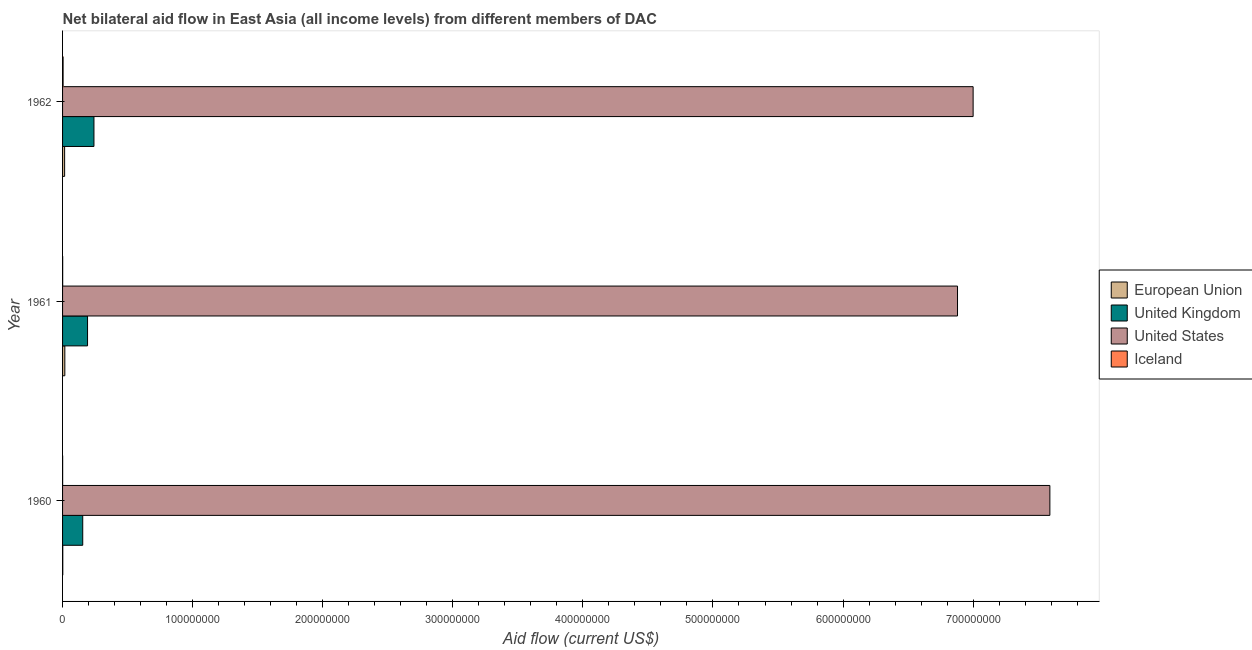How many different coloured bars are there?
Provide a succinct answer. 4. How many bars are there on the 1st tick from the top?
Keep it short and to the point. 4. What is the label of the 1st group of bars from the top?
Provide a short and direct response. 1962. In how many cases, is the number of bars for a given year not equal to the number of legend labels?
Provide a succinct answer. 0. What is the amount of aid given by uk in 1961?
Your response must be concise. 1.92e+07. Across all years, what is the maximum amount of aid given by us?
Your answer should be compact. 7.59e+08. Across all years, what is the minimum amount of aid given by uk?
Ensure brevity in your answer.  1.55e+07. In which year was the amount of aid given by iceland maximum?
Provide a succinct answer. 1962. In which year was the amount of aid given by iceland minimum?
Your answer should be very brief. 1960. What is the total amount of aid given by uk in the graph?
Your answer should be very brief. 5.88e+07. What is the difference between the amount of aid given by us in 1960 and that in 1961?
Provide a succinct answer. 7.10e+07. What is the difference between the amount of aid given by uk in 1961 and the amount of aid given by iceland in 1962?
Provide a succinct answer. 1.88e+07. What is the average amount of aid given by us per year?
Offer a terse response. 7.16e+08. In the year 1962, what is the difference between the amount of aid given by uk and amount of aid given by iceland?
Offer a terse response. 2.37e+07. In how many years, is the amount of aid given by uk greater than 740000000 US$?
Keep it short and to the point. 0. Is the amount of aid given by iceland in 1961 less than that in 1962?
Provide a succinct answer. Yes. Is the difference between the amount of aid given by us in 1960 and 1962 greater than the difference between the amount of aid given by uk in 1960 and 1962?
Give a very brief answer. Yes. What is the difference between the highest and the second highest amount of aid given by uk?
Ensure brevity in your answer.  4.92e+06. What is the difference between the highest and the lowest amount of aid given by iceland?
Your answer should be very brief. 3.40e+05. In how many years, is the amount of aid given by iceland greater than the average amount of aid given by iceland taken over all years?
Your answer should be compact. 1. Is the sum of the amount of aid given by us in 1960 and 1961 greater than the maximum amount of aid given by eu across all years?
Keep it short and to the point. Yes. What does the 3rd bar from the top in 1960 represents?
Your answer should be compact. United Kingdom. How many bars are there?
Provide a succinct answer. 12. Are all the bars in the graph horizontal?
Your answer should be very brief. Yes. How many years are there in the graph?
Ensure brevity in your answer.  3. Are the values on the major ticks of X-axis written in scientific E-notation?
Provide a short and direct response. No. Does the graph contain grids?
Provide a short and direct response. No. How many legend labels are there?
Offer a terse response. 4. How are the legend labels stacked?
Give a very brief answer. Vertical. What is the title of the graph?
Your answer should be compact. Net bilateral aid flow in East Asia (all income levels) from different members of DAC. Does "Periodicity assessment" appear as one of the legend labels in the graph?
Offer a terse response. No. What is the label or title of the Y-axis?
Offer a very short reply. Year. What is the Aid flow (current US$) of United Kingdom in 1960?
Make the answer very short. 1.55e+07. What is the Aid flow (current US$) of United States in 1960?
Your response must be concise. 7.59e+08. What is the Aid flow (current US$) in Iceland in 1960?
Your response must be concise. 6.00e+04. What is the Aid flow (current US$) of European Union in 1961?
Provide a short and direct response. 1.74e+06. What is the Aid flow (current US$) in United Kingdom in 1961?
Your answer should be very brief. 1.92e+07. What is the Aid flow (current US$) of United States in 1961?
Keep it short and to the point. 6.88e+08. What is the Aid flow (current US$) in Iceland in 1961?
Your response must be concise. 8.00e+04. What is the Aid flow (current US$) in European Union in 1962?
Provide a succinct answer. 1.58e+06. What is the Aid flow (current US$) of United Kingdom in 1962?
Keep it short and to the point. 2.41e+07. What is the Aid flow (current US$) of United States in 1962?
Give a very brief answer. 7.00e+08. Across all years, what is the maximum Aid flow (current US$) in European Union?
Keep it short and to the point. 1.74e+06. Across all years, what is the maximum Aid flow (current US$) in United Kingdom?
Provide a short and direct response. 2.41e+07. Across all years, what is the maximum Aid flow (current US$) of United States?
Your answer should be very brief. 7.59e+08. Across all years, what is the minimum Aid flow (current US$) in European Union?
Your answer should be very brief. 1.60e+05. Across all years, what is the minimum Aid flow (current US$) in United Kingdom?
Your answer should be compact. 1.55e+07. Across all years, what is the minimum Aid flow (current US$) of United States?
Your answer should be compact. 6.88e+08. What is the total Aid flow (current US$) in European Union in the graph?
Offer a terse response. 3.48e+06. What is the total Aid flow (current US$) of United Kingdom in the graph?
Keep it short and to the point. 5.88e+07. What is the total Aid flow (current US$) in United States in the graph?
Give a very brief answer. 2.15e+09. What is the total Aid flow (current US$) of Iceland in the graph?
Offer a terse response. 5.40e+05. What is the difference between the Aid flow (current US$) in European Union in 1960 and that in 1961?
Your response must be concise. -1.58e+06. What is the difference between the Aid flow (current US$) of United Kingdom in 1960 and that in 1961?
Provide a succinct answer. -3.70e+06. What is the difference between the Aid flow (current US$) of United States in 1960 and that in 1961?
Ensure brevity in your answer.  7.10e+07. What is the difference between the Aid flow (current US$) in European Union in 1960 and that in 1962?
Keep it short and to the point. -1.42e+06. What is the difference between the Aid flow (current US$) in United Kingdom in 1960 and that in 1962?
Your response must be concise. -8.62e+06. What is the difference between the Aid flow (current US$) of United States in 1960 and that in 1962?
Provide a succinct answer. 5.90e+07. What is the difference between the Aid flow (current US$) in Iceland in 1960 and that in 1962?
Provide a succinct answer. -3.40e+05. What is the difference between the Aid flow (current US$) of United Kingdom in 1961 and that in 1962?
Your answer should be very brief. -4.92e+06. What is the difference between the Aid flow (current US$) of United States in 1961 and that in 1962?
Give a very brief answer. -1.20e+07. What is the difference between the Aid flow (current US$) of Iceland in 1961 and that in 1962?
Ensure brevity in your answer.  -3.20e+05. What is the difference between the Aid flow (current US$) in European Union in 1960 and the Aid flow (current US$) in United Kingdom in 1961?
Provide a succinct answer. -1.90e+07. What is the difference between the Aid flow (current US$) in European Union in 1960 and the Aid flow (current US$) in United States in 1961?
Your response must be concise. -6.88e+08. What is the difference between the Aid flow (current US$) of European Union in 1960 and the Aid flow (current US$) of Iceland in 1961?
Your response must be concise. 8.00e+04. What is the difference between the Aid flow (current US$) of United Kingdom in 1960 and the Aid flow (current US$) of United States in 1961?
Provide a short and direct response. -6.72e+08. What is the difference between the Aid flow (current US$) of United Kingdom in 1960 and the Aid flow (current US$) of Iceland in 1961?
Keep it short and to the point. 1.54e+07. What is the difference between the Aid flow (current US$) in United States in 1960 and the Aid flow (current US$) in Iceland in 1961?
Give a very brief answer. 7.59e+08. What is the difference between the Aid flow (current US$) of European Union in 1960 and the Aid flow (current US$) of United Kingdom in 1962?
Your answer should be very brief. -2.40e+07. What is the difference between the Aid flow (current US$) in European Union in 1960 and the Aid flow (current US$) in United States in 1962?
Your answer should be compact. -7.00e+08. What is the difference between the Aid flow (current US$) of European Union in 1960 and the Aid flow (current US$) of Iceland in 1962?
Keep it short and to the point. -2.40e+05. What is the difference between the Aid flow (current US$) of United Kingdom in 1960 and the Aid flow (current US$) of United States in 1962?
Your answer should be compact. -6.84e+08. What is the difference between the Aid flow (current US$) of United Kingdom in 1960 and the Aid flow (current US$) of Iceland in 1962?
Your response must be concise. 1.51e+07. What is the difference between the Aid flow (current US$) in United States in 1960 and the Aid flow (current US$) in Iceland in 1962?
Your answer should be very brief. 7.59e+08. What is the difference between the Aid flow (current US$) in European Union in 1961 and the Aid flow (current US$) in United Kingdom in 1962?
Your response must be concise. -2.24e+07. What is the difference between the Aid flow (current US$) of European Union in 1961 and the Aid flow (current US$) of United States in 1962?
Give a very brief answer. -6.98e+08. What is the difference between the Aid flow (current US$) in European Union in 1961 and the Aid flow (current US$) in Iceland in 1962?
Your response must be concise. 1.34e+06. What is the difference between the Aid flow (current US$) in United Kingdom in 1961 and the Aid flow (current US$) in United States in 1962?
Provide a succinct answer. -6.81e+08. What is the difference between the Aid flow (current US$) of United Kingdom in 1961 and the Aid flow (current US$) of Iceland in 1962?
Provide a succinct answer. 1.88e+07. What is the difference between the Aid flow (current US$) in United States in 1961 and the Aid flow (current US$) in Iceland in 1962?
Ensure brevity in your answer.  6.88e+08. What is the average Aid flow (current US$) in European Union per year?
Keep it short and to the point. 1.16e+06. What is the average Aid flow (current US$) of United Kingdom per year?
Make the answer very short. 1.96e+07. What is the average Aid flow (current US$) in United States per year?
Your answer should be very brief. 7.16e+08. What is the average Aid flow (current US$) in Iceland per year?
Keep it short and to the point. 1.80e+05. In the year 1960, what is the difference between the Aid flow (current US$) of European Union and Aid flow (current US$) of United Kingdom?
Your answer should be very brief. -1.54e+07. In the year 1960, what is the difference between the Aid flow (current US$) of European Union and Aid flow (current US$) of United States?
Offer a terse response. -7.59e+08. In the year 1960, what is the difference between the Aid flow (current US$) of United Kingdom and Aid flow (current US$) of United States?
Give a very brief answer. -7.43e+08. In the year 1960, what is the difference between the Aid flow (current US$) in United Kingdom and Aid flow (current US$) in Iceland?
Keep it short and to the point. 1.54e+07. In the year 1960, what is the difference between the Aid flow (current US$) in United States and Aid flow (current US$) in Iceland?
Make the answer very short. 7.59e+08. In the year 1961, what is the difference between the Aid flow (current US$) in European Union and Aid flow (current US$) in United Kingdom?
Make the answer very short. -1.75e+07. In the year 1961, what is the difference between the Aid flow (current US$) of European Union and Aid flow (current US$) of United States?
Offer a very short reply. -6.86e+08. In the year 1961, what is the difference between the Aid flow (current US$) of European Union and Aid flow (current US$) of Iceland?
Offer a very short reply. 1.66e+06. In the year 1961, what is the difference between the Aid flow (current US$) of United Kingdom and Aid flow (current US$) of United States?
Offer a terse response. -6.69e+08. In the year 1961, what is the difference between the Aid flow (current US$) in United Kingdom and Aid flow (current US$) in Iceland?
Give a very brief answer. 1.91e+07. In the year 1961, what is the difference between the Aid flow (current US$) in United States and Aid flow (current US$) in Iceland?
Offer a very short reply. 6.88e+08. In the year 1962, what is the difference between the Aid flow (current US$) of European Union and Aid flow (current US$) of United Kingdom?
Your answer should be very brief. -2.26e+07. In the year 1962, what is the difference between the Aid flow (current US$) in European Union and Aid flow (current US$) in United States?
Provide a short and direct response. -6.98e+08. In the year 1962, what is the difference between the Aid flow (current US$) in European Union and Aid flow (current US$) in Iceland?
Your response must be concise. 1.18e+06. In the year 1962, what is the difference between the Aid flow (current US$) of United Kingdom and Aid flow (current US$) of United States?
Make the answer very short. -6.76e+08. In the year 1962, what is the difference between the Aid flow (current US$) of United Kingdom and Aid flow (current US$) of Iceland?
Keep it short and to the point. 2.37e+07. In the year 1962, what is the difference between the Aid flow (current US$) of United States and Aid flow (current US$) of Iceland?
Provide a succinct answer. 7.00e+08. What is the ratio of the Aid flow (current US$) in European Union in 1960 to that in 1961?
Your answer should be very brief. 0.09. What is the ratio of the Aid flow (current US$) in United Kingdom in 1960 to that in 1961?
Offer a terse response. 0.81. What is the ratio of the Aid flow (current US$) in United States in 1960 to that in 1961?
Provide a short and direct response. 1.1. What is the ratio of the Aid flow (current US$) of European Union in 1960 to that in 1962?
Provide a short and direct response. 0.1. What is the ratio of the Aid flow (current US$) of United Kingdom in 1960 to that in 1962?
Keep it short and to the point. 0.64. What is the ratio of the Aid flow (current US$) of United States in 1960 to that in 1962?
Make the answer very short. 1.08. What is the ratio of the Aid flow (current US$) of Iceland in 1960 to that in 1962?
Make the answer very short. 0.15. What is the ratio of the Aid flow (current US$) in European Union in 1961 to that in 1962?
Ensure brevity in your answer.  1.1. What is the ratio of the Aid flow (current US$) of United Kingdom in 1961 to that in 1962?
Provide a succinct answer. 0.8. What is the ratio of the Aid flow (current US$) in United States in 1961 to that in 1962?
Offer a very short reply. 0.98. What is the ratio of the Aid flow (current US$) in Iceland in 1961 to that in 1962?
Offer a terse response. 0.2. What is the difference between the highest and the second highest Aid flow (current US$) of United Kingdom?
Give a very brief answer. 4.92e+06. What is the difference between the highest and the second highest Aid flow (current US$) of United States?
Your answer should be compact. 5.90e+07. What is the difference between the highest and the lowest Aid flow (current US$) in European Union?
Give a very brief answer. 1.58e+06. What is the difference between the highest and the lowest Aid flow (current US$) of United Kingdom?
Your answer should be compact. 8.62e+06. What is the difference between the highest and the lowest Aid flow (current US$) in United States?
Your answer should be compact. 7.10e+07. 